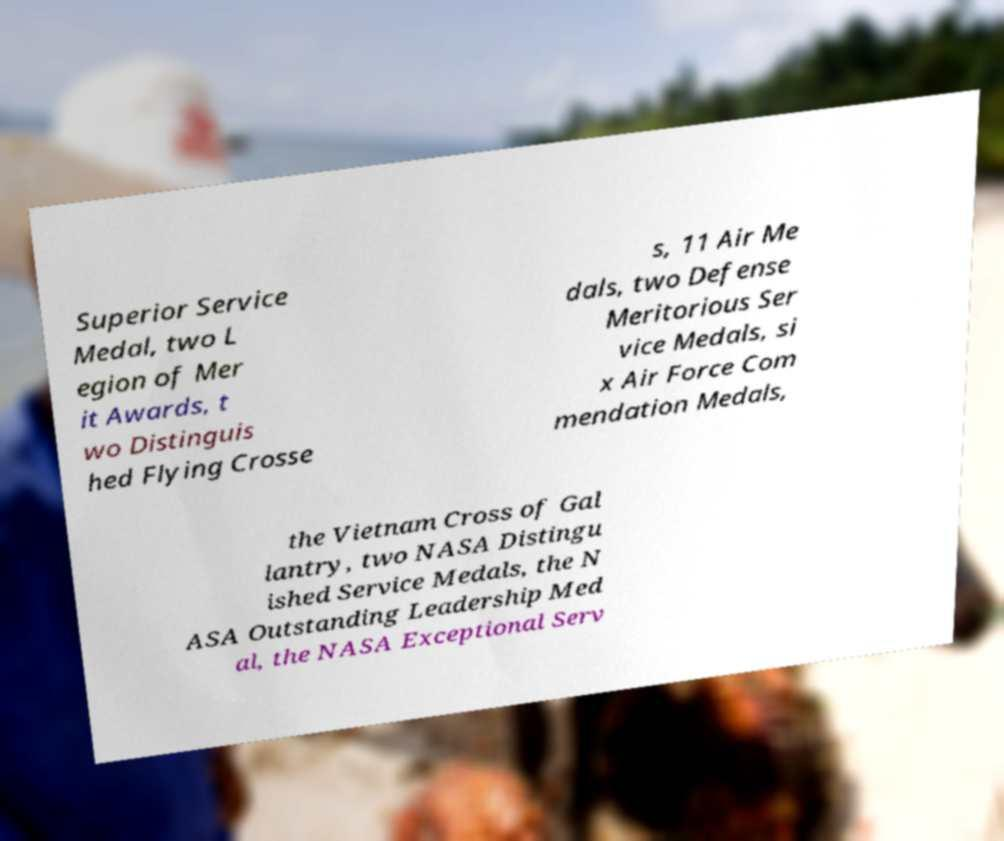Could you extract and type out the text from this image? Superior Service Medal, two L egion of Mer it Awards, t wo Distinguis hed Flying Crosse s, 11 Air Me dals, two Defense Meritorious Ser vice Medals, si x Air Force Com mendation Medals, the Vietnam Cross of Gal lantry, two NASA Distingu ished Service Medals, the N ASA Outstanding Leadership Med al, the NASA Exceptional Serv 